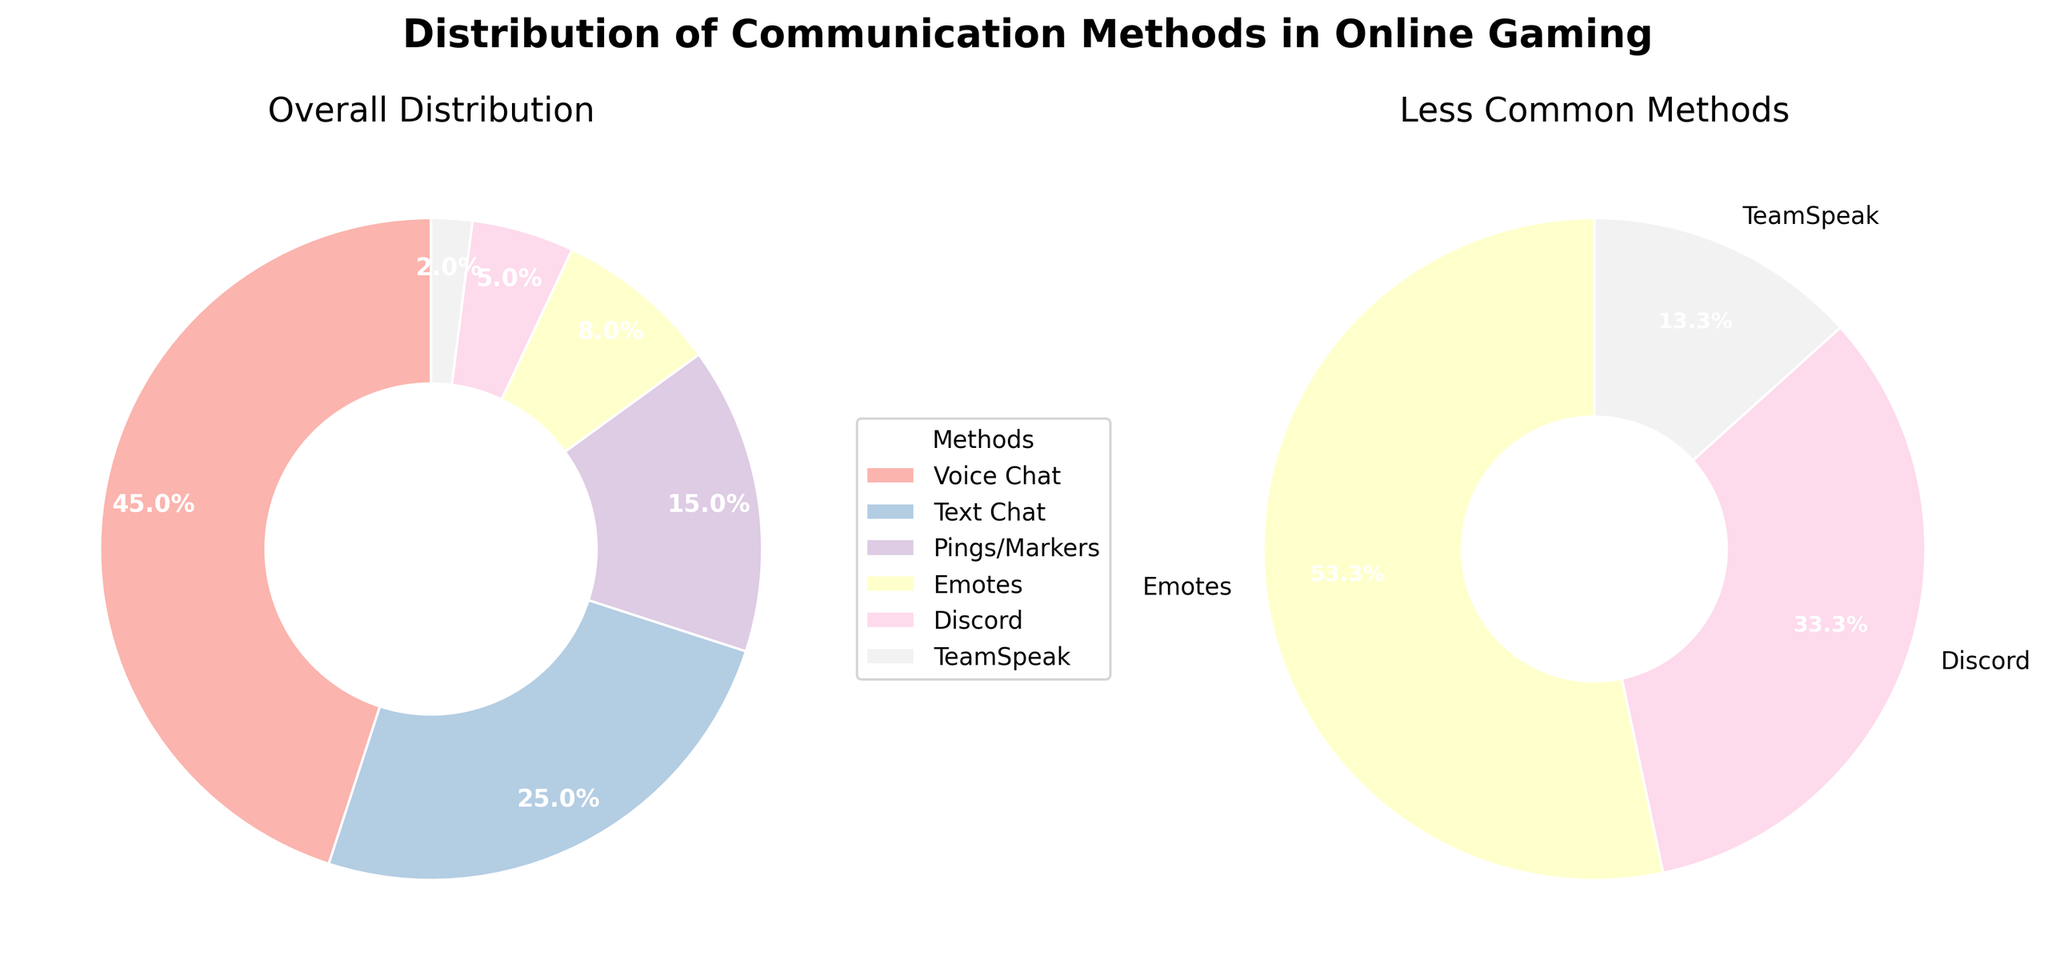What is the title of the figure? The title is shown at the top of the figure and describes the content depicted in the plot.
Answer: Distribution of Communication Methods in Online Gaming Which communication method has the highest percentage of use? The largest wedge in the "Overall Distribution" pie chart represents the method with the highest percentage. Based on the data provided, it's the first method listed with the highest percentage.
Answer: Voice Chat How many communication methods are displayed in the "Less Common Methods" pie chart? Count the number of wedges in the smaller pie chart. These represent methods with less than 10% usage.
Answer: 4 What is the combined percentage of Text Chat and Discord in online gaming communication? Add the percentages for Text Chat (25%) and Discord (5%).
Answer: 30% Which communication method has a lower percentage of use, Emotes or Pings/Markers? Compare the sizes of the wedges representing Emotes and Pings/Markers in the "Overall Distribution" pie chart or the percentages provided.
Answer: Emotes What is the total percentage of all the communication methods that have less than 10% of usage? Sum the percentages of the methods in the "Less Common Methods" pie chart: Emotes (8%), Discord (5%), TeamSpeak (2%), and any additional segment if shown.
Answer: 15% How do "Text Chat" and "Voice Chat" compare in terms of their usage percentage? Look at their corresponding wedges in the "Overall Distribution" pie chart and compare their percentages. Text Chat is less used than Voice Chat (25% vs. 45%).
Answer: Text Chat is less used than Voice Chat Which color represents TeamSpeak in the figure? Identify the color assigned to the wedge of TeamSpeak in the "Overall Distribution" pie chart, as described by the provided colors palette.
Answer: Light pink (based on Pastel1 color palette) What percentage of online gamers use non-verbal communication methods (Pings/Markers and Emotes)? Add the percentages for Pings/Markers (15%) and Emotes (8%).
Answer: 23% What portion of communication methods used by online gamers are visualized in the main pie chart (Overall Distribution)? Since the main pie chart shows all data points, the entire 100% distribution is represented.
Answer: 100% 